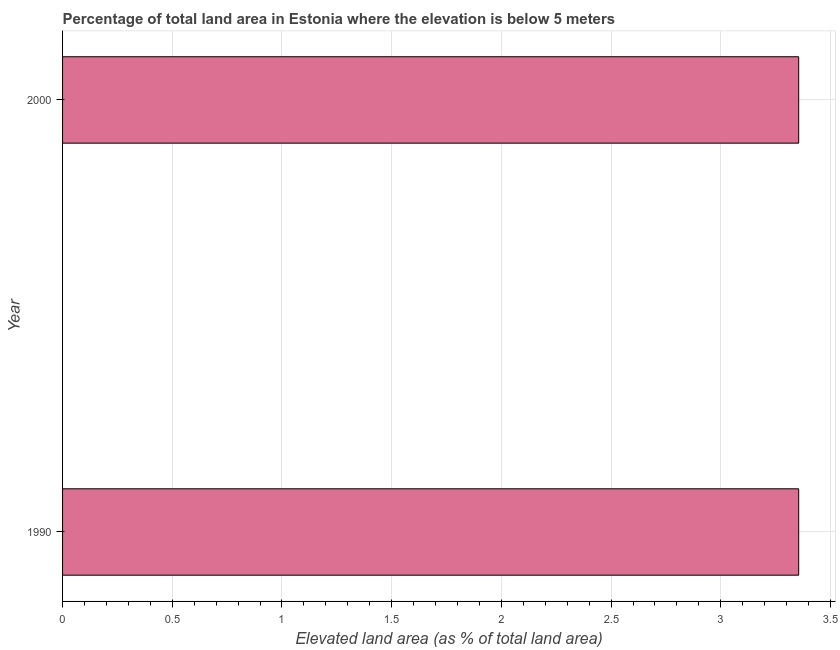Does the graph contain grids?
Offer a very short reply. Yes. What is the title of the graph?
Give a very brief answer. Percentage of total land area in Estonia where the elevation is below 5 meters. What is the label or title of the X-axis?
Provide a succinct answer. Elevated land area (as % of total land area). What is the label or title of the Y-axis?
Your answer should be compact. Year. What is the total elevated land area in 1990?
Provide a succinct answer. 3.35. Across all years, what is the maximum total elevated land area?
Your answer should be very brief. 3.35. Across all years, what is the minimum total elevated land area?
Provide a short and direct response. 3.35. In which year was the total elevated land area maximum?
Offer a very short reply. 1990. In which year was the total elevated land area minimum?
Offer a very short reply. 1990. What is the sum of the total elevated land area?
Offer a terse response. 6.71. What is the average total elevated land area per year?
Offer a very short reply. 3.35. What is the median total elevated land area?
Ensure brevity in your answer.  3.35. What is the ratio of the total elevated land area in 1990 to that in 2000?
Your response must be concise. 1. Are all the bars in the graph horizontal?
Offer a very short reply. Yes. How many years are there in the graph?
Provide a short and direct response. 2. What is the difference between two consecutive major ticks on the X-axis?
Your answer should be very brief. 0.5. What is the Elevated land area (as % of total land area) of 1990?
Give a very brief answer. 3.35. What is the Elevated land area (as % of total land area) of 2000?
Give a very brief answer. 3.35. 